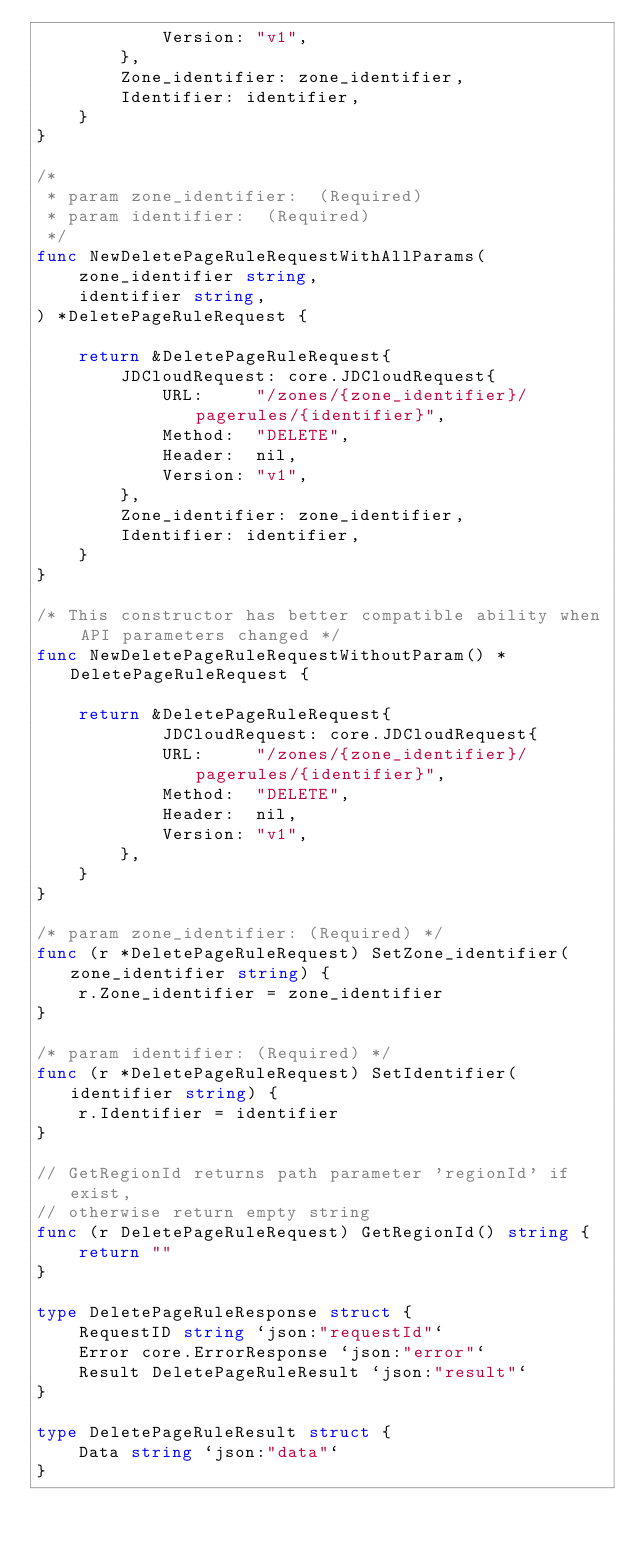Convert code to text. <code><loc_0><loc_0><loc_500><loc_500><_Go_>			Version: "v1",
		},
        Zone_identifier: zone_identifier,
        Identifier: identifier,
	}
}

/*
 * param zone_identifier:  (Required)
 * param identifier:  (Required)
 */
func NewDeletePageRuleRequestWithAllParams(
    zone_identifier string,
    identifier string,
) *DeletePageRuleRequest {

    return &DeletePageRuleRequest{
        JDCloudRequest: core.JDCloudRequest{
            URL:     "/zones/{zone_identifier}/pagerules/{identifier}",
            Method:  "DELETE",
            Header:  nil,
            Version: "v1",
        },
        Zone_identifier: zone_identifier,
        Identifier: identifier,
    }
}

/* This constructor has better compatible ability when API parameters changed */
func NewDeletePageRuleRequestWithoutParam() *DeletePageRuleRequest {

    return &DeletePageRuleRequest{
            JDCloudRequest: core.JDCloudRequest{
            URL:     "/zones/{zone_identifier}/pagerules/{identifier}",
            Method:  "DELETE",
            Header:  nil,
            Version: "v1",
        },
    }
}

/* param zone_identifier: (Required) */
func (r *DeletePageRuleRequest) SetZone_identifier(zone_identifier string) {
    r.Zone_identifier = zone_identifier
}

/* param identifier: (Required) */
func (r *DeletePageRuleRequest) SetIdentifier(identifier string) {
    r.Identifier = identifier
}

// GetRegionId returns path parameter 'regionId' if exist,
// otherwise return empty string
func (r DeletePageRuleRequest) GetRegionId() string {
    return ""
}

type DeletePageRuleResponse struct {
    RequestID string `json:"requestId"`
    Error core.ErrorResponse `json:"error"`
    Result DeletePageRuleResult `json:"result"`
}

type DeletePageRuleResult struct {
    Data string `json:"data"`
}</code> 